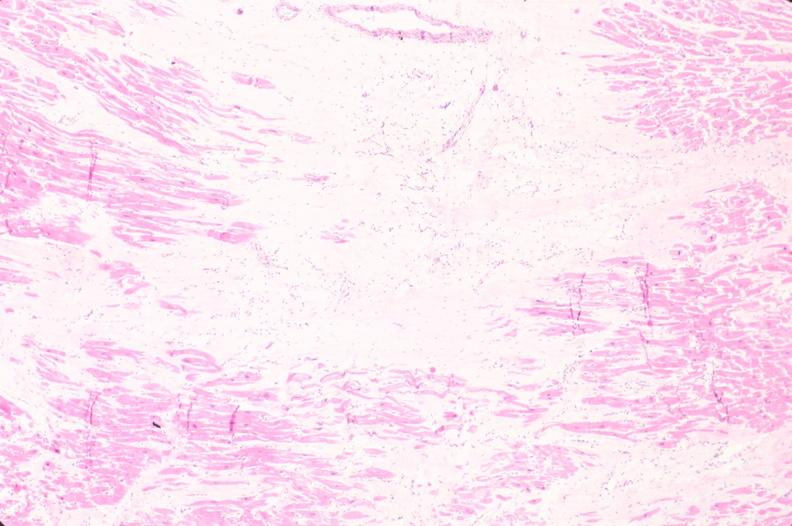what is present?
Answer the question using a single word or phrase. Cardiovascular 